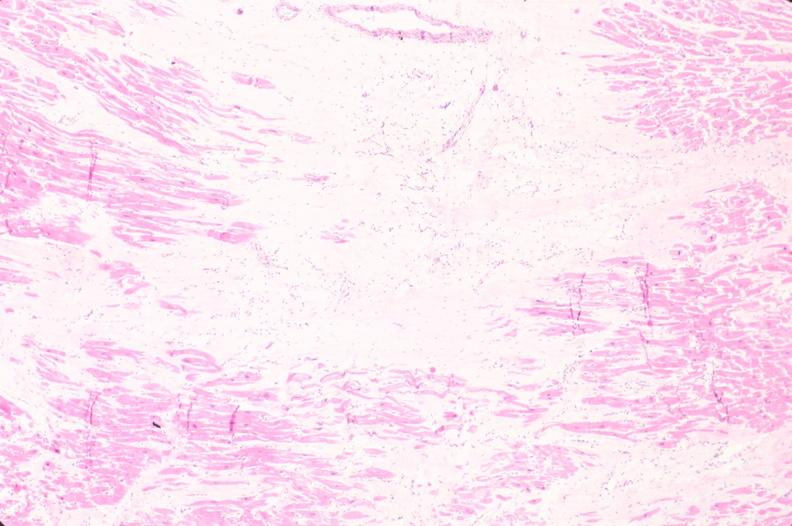what is present?
Answer the question using a single word or phrase. Cardiovascular 